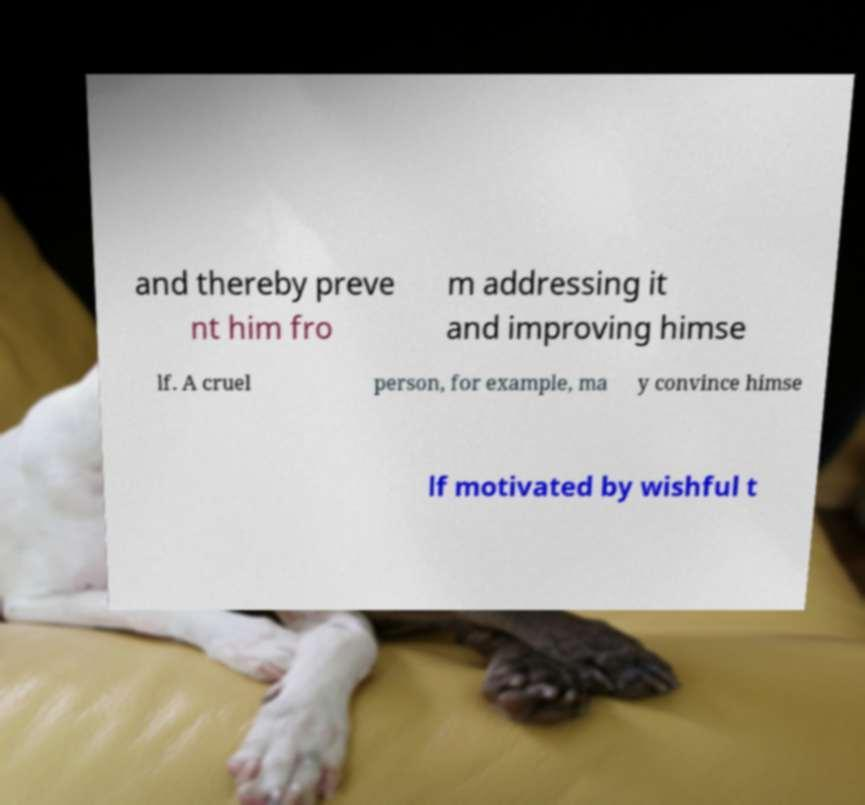Can you accurately transcribe the text from the provided image for me? and thereby preve nt him fro m addressing it and improving himse lf. A cruel person, for example, ma y convince himse lf motivated by wishful t 